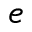Convert formula to latex. <formula><loc_0><loc_0><loc_500><loc_500>e</formula> 